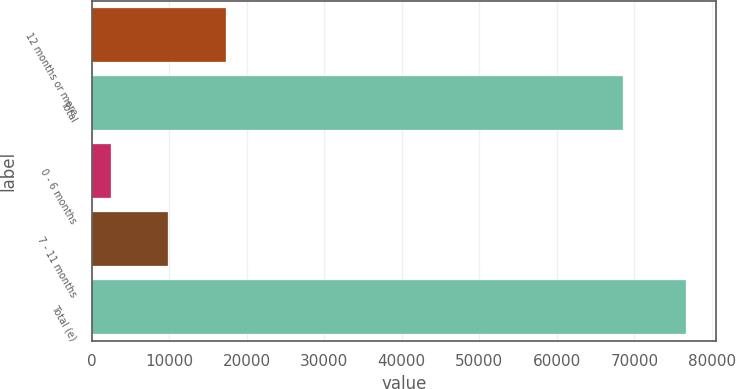<chart> <loc_0><loc_0><loc_500><loc_500><bar_chart><fcel>12 months or more<fcel>Total<fcel>0 - 6 months<fcel>7 - 11 months<fcel>Total (e)<nl><fcel>17335<fcel>68509<fcel>2499<fcel>9917<fcel>76679<nl></chart> 